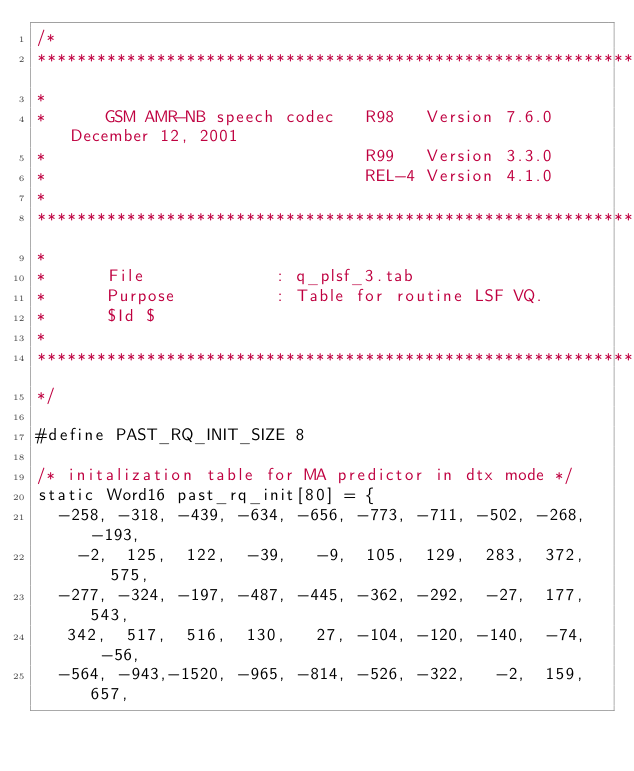<code> <loc_0><loc_0><loc_500><loc_500><_SQL_>/*
********************************************************************************
*
*      GSM AMR-NB speech codec   R98   Version 7.6.0   December 12, 2001
*                                R99   Version 3.3.0
*                                REL-4 Version 4.1.0
*
********************************************************************************
*
*      File             : q_plsf_3.tab
*      Purpose          : Table for routine LSF VQ.
*      $Id $
*
********************************************************************************
*/

#define PAST_RQ_INIT_SIZE 8

/* initalization table for MA predictor in dtx mode */
static Word16 past_rq_init[80] = {
  -258, -318, -439, -634, -656, -773, -711, -502, -268, -193,
    -2,  125,  122,  -39,   -9,  105,  129,  283,  372,  575,
  -277, -324, -197, -487, -445, -362, -292,  -27,  177,  543,
   342,  517,  516,  130,   27, -104, -120, -140,  -74,  -56,
  -564, -943,-1520, -965, -814, -526, -322,   -2,  159,  657,</code> 